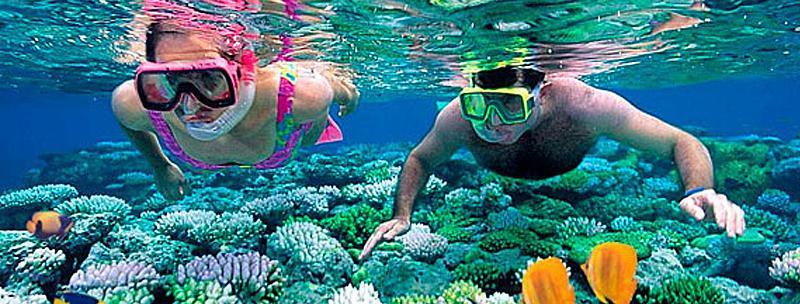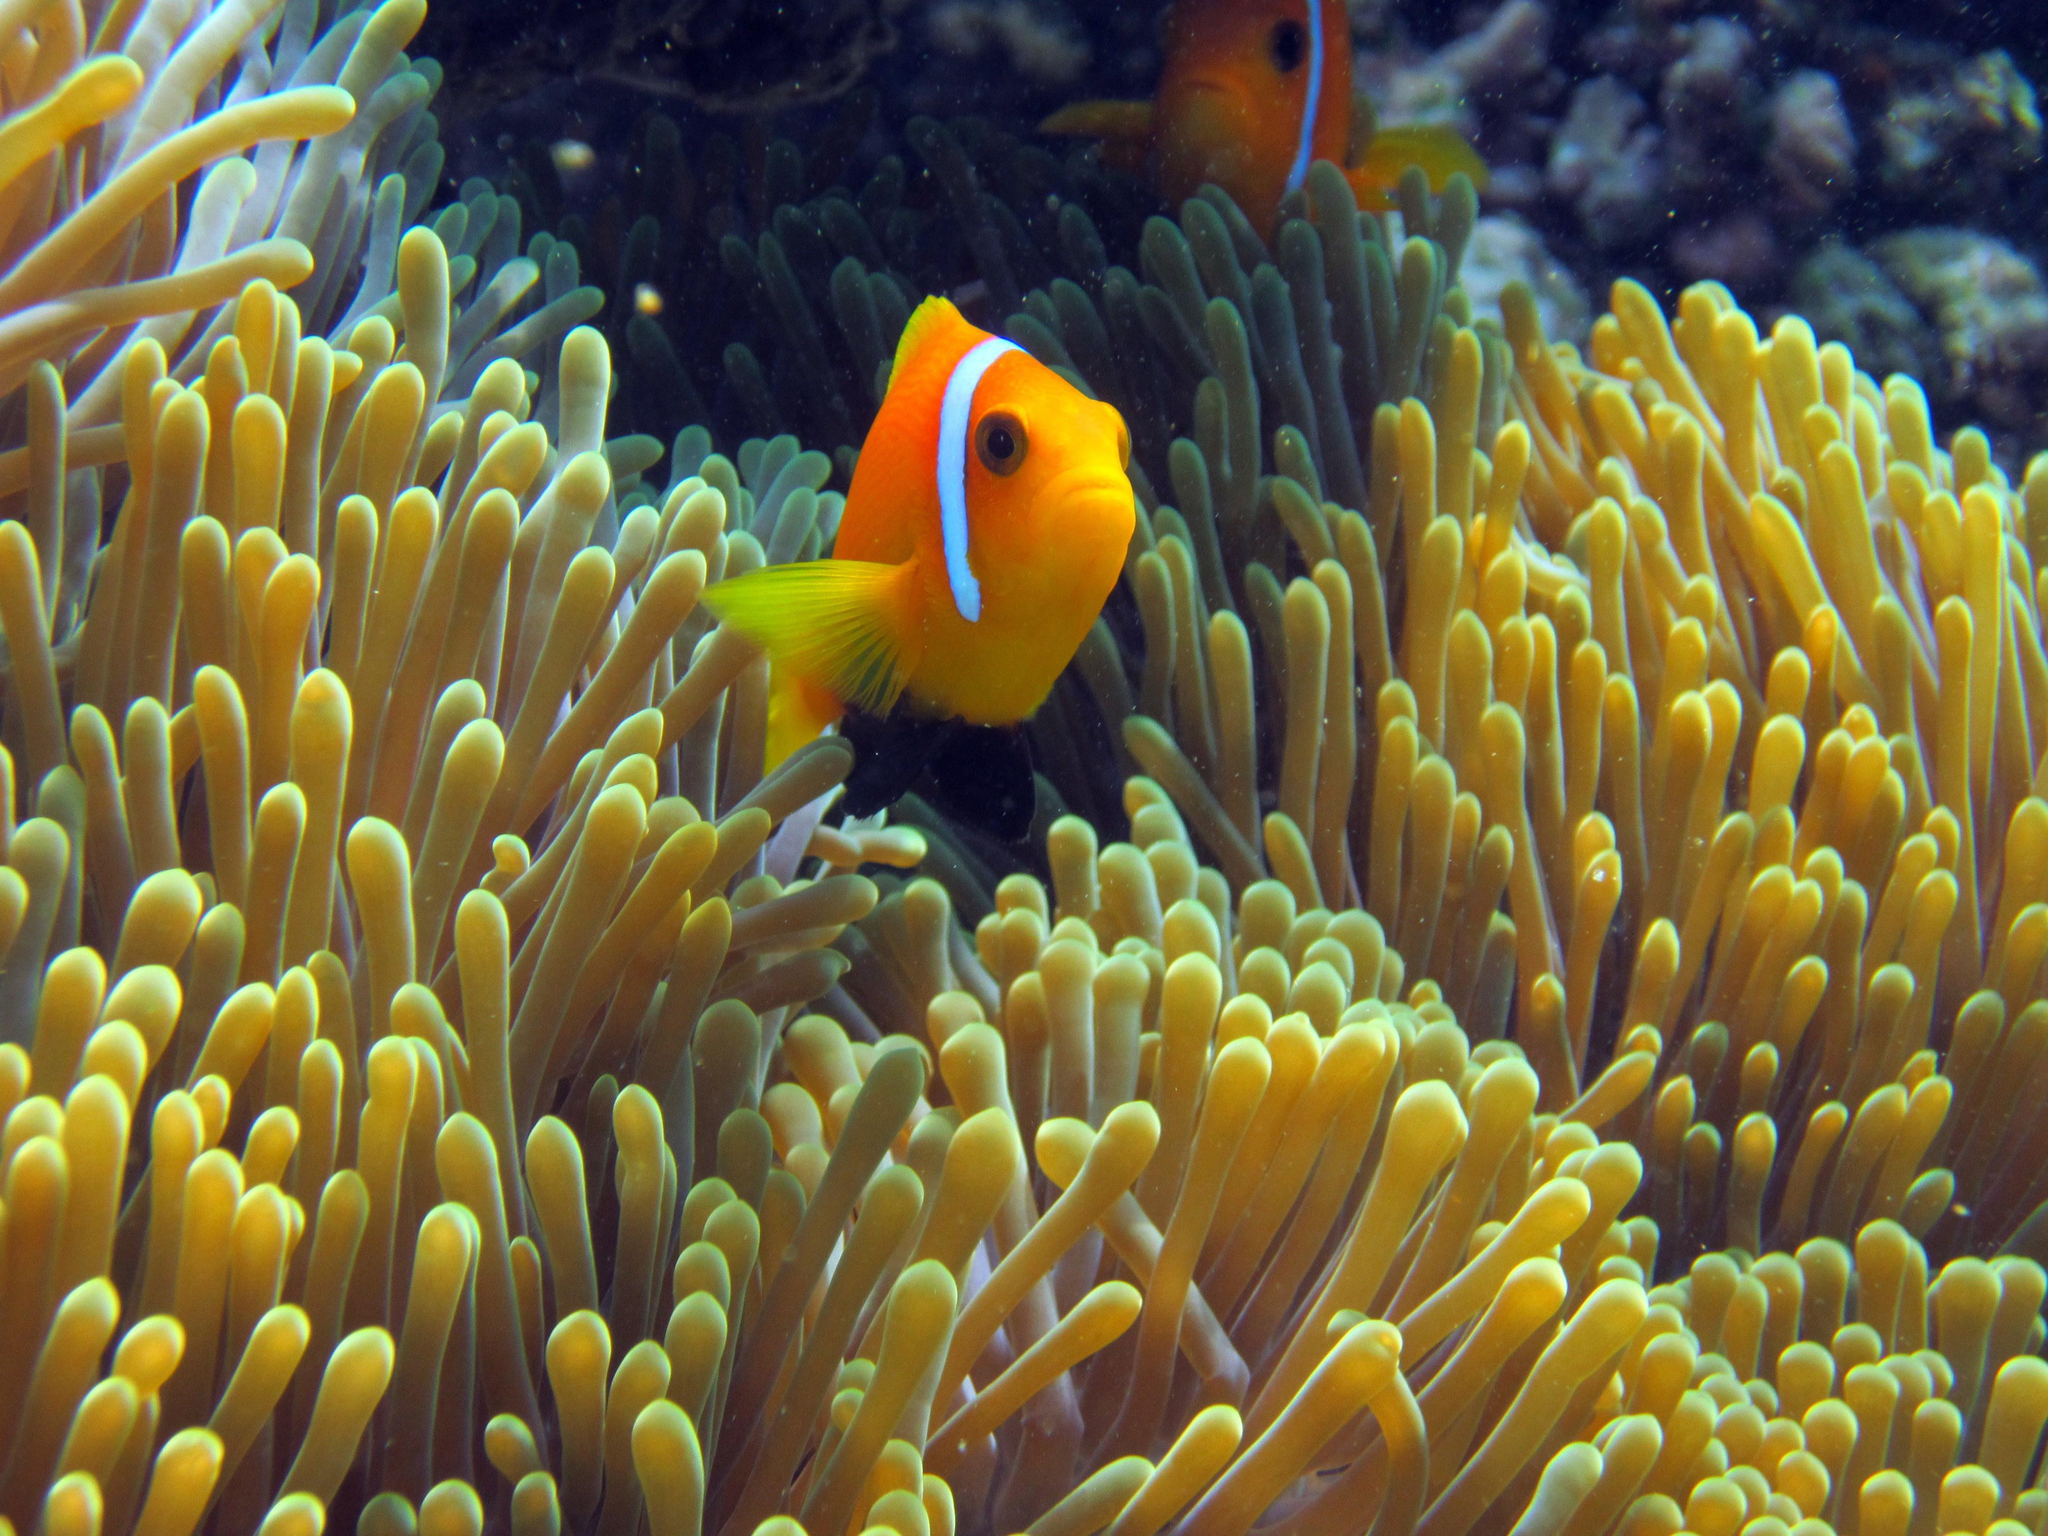The first image is the image on the left, the second image is the image on the right. Examine the images to the left and right. Is the description "In one of the images in each pair are two fish in anenome tentacles." accurate? Answer yes or no. No. 